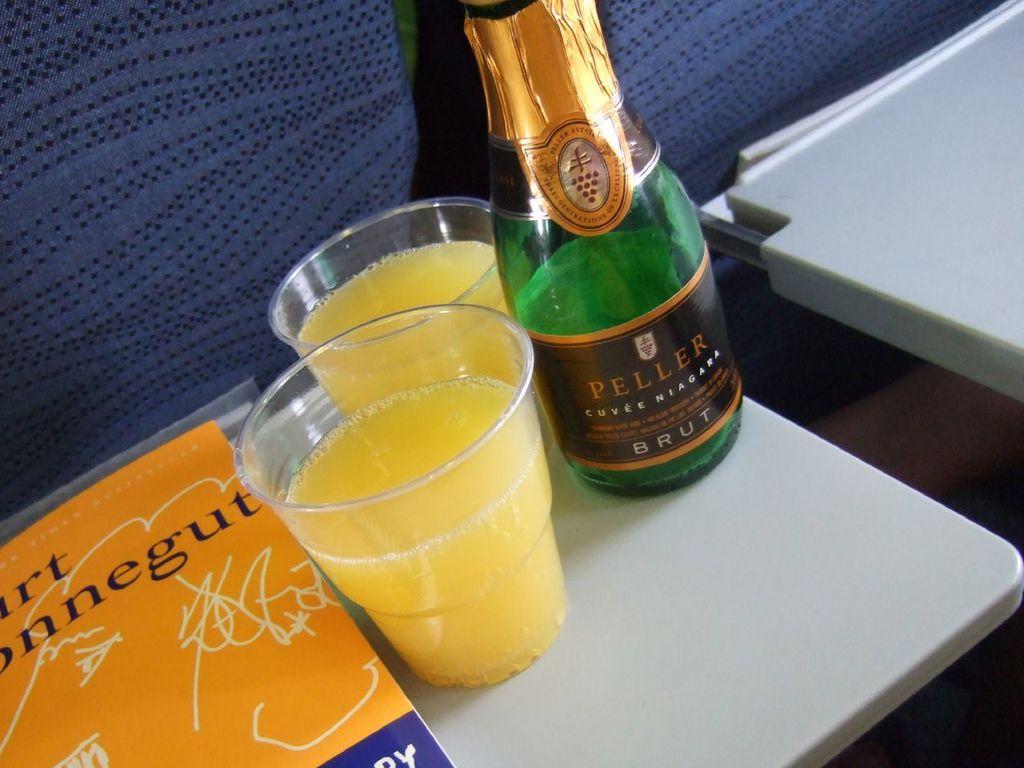Could you give a brief overview of what you see in this image? In this image i can see a green color glass bottle and two cups and a book on a table. 